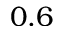Convert formula to latex. <formula><loc_0><loc_0><loc_500><loc_500>0 . 6</formula> 